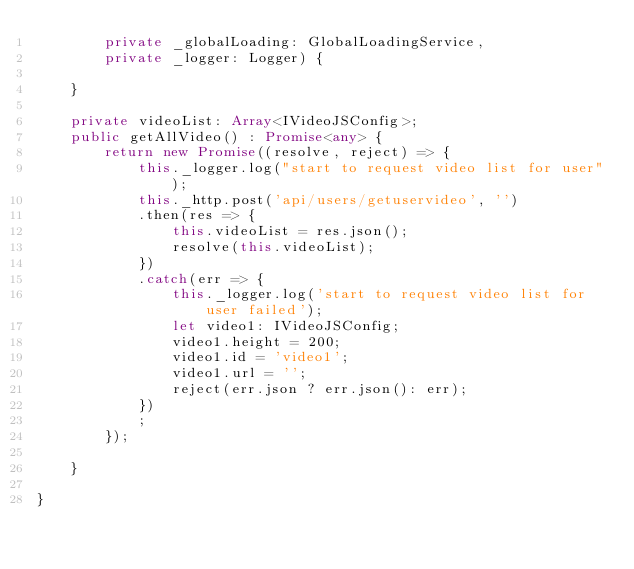<code> <loc_0><loc_0><loc_500><loc_500><_TypeScript_>        private _globalLoading: GlobalLoadingService, 
        private _logger: Logger) {
        
    }

    private videoList: Array<IVideoJSConfig>;
    public getAllVideo() : Promise<any> {
        return new Promise((resolve, reject) => {
            this._logger.log("start to request video list for user");
            this._http.post('api/users/getuservideo', '')
            .then(res => {
                this.videoList = res.json();
                resolve(this.videoList);
            })
            .catch(err => {
                this._logger.log('start to request video list for user failed');
                let video1: IVideoJSConfig;
                video1.height = 200;
                video1.id = 'video1';
                video1.url = '';
                reject(err.json ? err.json(): err);
            })
            ;
        });

    }

}</code> 